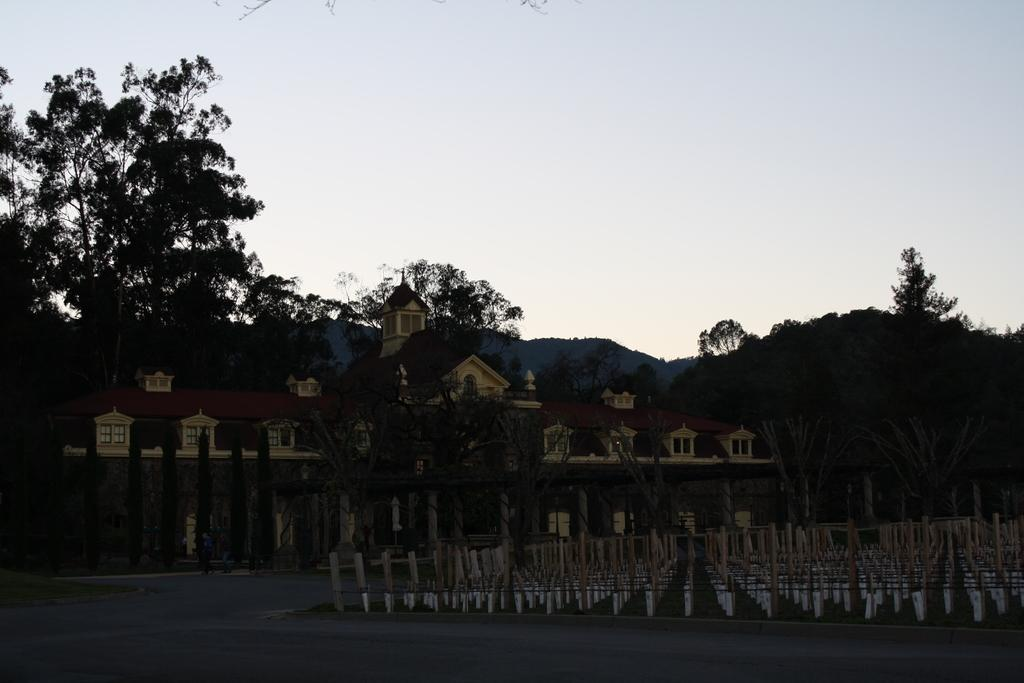What type of pathway is visible in the image? There is a road in the image. What structures can be seen alongside the road? There are poles and trees visible in the image. What type of structure is present in the image? There is a building in the image. What can be seen in the background of the image? The sky is visible in the background of the image. What type of ink is used to write on the store's sign in the image? There is no store present in the image, so there is no sign to write on and no ink to consider. 